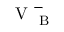<formula> <loc_0><loc_0><loc_500><loc_500>V _ { B } ^ { - }</formula> 